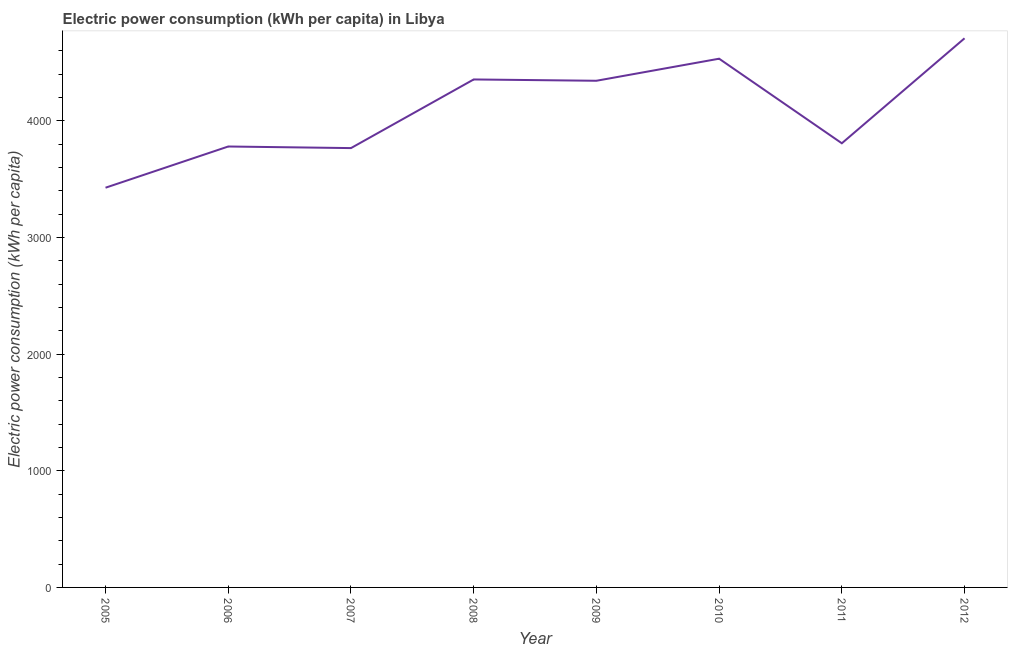What is the electric power consumption in 2006?
Your response must be concise. 3779.32. Across all years, what is the maximum electric power consumption?
Offer a very short reply. 4706.84. Across all years, what is the minimum electric power consumption?
Give a very brief answer. 3426.16. What is the sum of the electric power consumption?
Offer a terse response. 3.27e+04. What is the difference between the electric power consumption in 2006 and 2007?
Make the answer very short. 13.65. What is the average electric power consumption per year?
Provide a short and direct response. 4089.23. What is the median electric power consumption?
Provide a short and direct response. 4074.9. Do a majority of the years between 2006 and 2012 (inclusive) have electric power consumption greater than 2200 kWh per capita?
Make the answer very short. Yes. What is the ratio of the electric power consumption in 2006 to that in 2007?
Provide a short and direct response. 1. Is the electric power consumption in 2006 less than that in 2010?
Offer a very short reply. Yes. What is the difference between the highest and the second highest electric power consumption?
Keep it short and to the point. 174.87. What is the difference between the highest and the lowest electric power consumption?
Ensure brevity in your answer.  1280.69. Does the electric power consumption monotonically increase over the years?
Your answer should be compact. No. How many lines are there?
Make the answer very short. 1. What is the difference between two consecutive major ticks on the Y-axis?
Your answer should be compact. 1000. What is the title of the graph?
Provide a short and direct response. Electric power consumption (kWh per capita) in Libya. What is the label or title of the X-axis?
Provide a short and direct response. Year. What is the label or title of the Y-axis?
Ensure brevity in your answer.  Electric power consumption (kWh per capita). What is the Electric power consumption (kWh per capita) of 2005?
Your answer should be very brief. 3426.16. What is the Electric power consumption (kWh per capita) in 2006?
Provide a succinct answer. 3779.32. What is the Electric power consumption (kWh per capita) in 2007?
Your response must be concise. 3765.67. What is the Electric power consumption (kWh per capita) in 2008?
Give a very brief answer. 4354.06. What is the Electric power consumption (kWh per capita) in 2009?
Give a very brief answer. 4342.79. What is the Electric power consumption (kWh per capita) in 2010?
Your answer should be very brief. 4531.98. What is the Electric power consumption (kWh per capita) in 2011?
Provide a short and direct response. 3807.02. What is the Electric power consumption (kWh per capita) of 2012?
Provide a short and direct response. 4706.84. What is the difference between the Electric power consumption (kWh per capita) in 2005 and 2006?
Your response must be concise. -353.16. What is the difference between the Electric power consumption (kWh per capita) in 2005 and 2007?
Provide a short and direct response. -339.51. What is the difference between the Electric power consumption (kWh per capita) in 2005 and 2008?
Offer a terse response. -927.9. What is the difference between the Electric power consumption (kWh per capita) in 2005 and 2009?
Offer a very short reply. -916.63. What is the difference between the Electric power consumption (kWh per capita) in 2005 and 2010?
Provide a short and direct response. -1105.82. What is the difference between the Electric power consumption (kWh per capita) in 2005 and 2011?
Ensure brevity in your answer.  -380.86. What is the difference between the Electric power consumption (kWh per capita) in 2005 and 2012?
Keep it short and to the point. -1280.69. What is the difference between the Electric power consumption (kWh per capita) in 2006 and 2007?
Your response must be concise. 13.65. What is the difference between the Electric power consumption (kWh per capita) in 2006 and 2008?
Offer a terse response. -574.74. What is the difference between the Electric power consumption (kWh per capita) in 2006 and 2009?
Provide a short and direct response. -563.47. What is the difference between the Electric power consumption (kWh per capita) in 2006 and 2010?
Your answer should be compact. -752.66. What is the difference between the Electric power consumption (kWh per capita) in 2006 and 2011?
Your response must be concise. -27.7. What is the difference between the Electric power consumption (kWh per capita) in 2006 and 2012?
Ensure brevity in your answer.  -927.53. What is the difference between the Electric power consumption (kWh per capita) in 2007 and 2008?
Your response must be concise. -588.39. What is the difference between the Electric power consumption (kWh per capita) in 2007 and 2009?
Your answer should be compact. -577.13. What is the difference between the Electric power consumption (kWh per capita) in 2007 and 2010?
Provide a short and direct response. -766.31. What is the difference between the Electric power consumption (kWh per capita) in 2007 and 2011?
Give a very brief answer. -41.35. What is the difference between the Electric power consumption (kWh per capita) in 2007 and 2012?
Ensure brevity in your answer.  -941.18. What is the difference between the Electric power consumption (kWh per capita) in 2008 and 2009?
Your answer should be compact. 11.27. What is the difference between the Electric power consumption (kWh per capita) in 2008 and 2010?
Offer a terse response. -177.92. What is the difference between the Electric power consumption (kWh per capita) in 2008 and 2011?
Keep it short and to the point. 547.04. What is the difference between the Electric power consumption (kWh per capita) in 2008 and 2012?
Offer a very short reply. -352.79. What is the difference between the Electric power consumption (kWh per capita) in 2009 and 2010?
Give a very brief answer. -189.19. What is the difference between the Electric power consumption (kWh per capita) in 2009 and 2011?
Provide a short and direct response. 535.77. What is the difference between the Electric power consumption (kWh per capita) in 2009 and 2012?
Make the answer very short. -364.05. What is the difference between the Electric power consumption (kWh per capita) in 2010 and 2011?
Provide a succinct answer. 724.96. What is the difference between the Electric power consumption (kWh per capita) in 2010 and 2012?
Your answer should be compact. -174.87. What is the difference between the Electric power consumption (kWh per capita) in 2011 and 2012?
Give a very brief answer. -899.83. What is the ratio of the Electric power consumption (kWh per capita) in 2005 to that in 2006?
Offer a very short reply. 0.91. What is the ratio of the Electric power consumption (kWh per capita) in 2005 to that in 2007?
Give a very brief answer. 0.91. What is the ratio of the Electric power consumption (kWh per capita) in 2005 to that in 2008?
Ensure brevity in your answer.  0.79. What is the ratio of the Electric power consumption (kWh per capita) in 2005 to that in 2009?
Your answer should be very brief. 0.79. What is the ratio of the Electric power consumption (kWh per capita) in 2005 to that in 2010?
Keep it short and to the point. 0.76. What is the ratio of the Electric power consumption (kWh per capita) in 2005 to that in 2011?
Provide a succinct answer. 0.9. What is the ratio of the Electric power consumption (kWh per capita) in 2005 to that in 2012?
Offer a terse response. 0.73. What is the ratio of the Electric power consumption (kWh per capita) in 2006 to that in 2008?
Provide a succinct answer. 0.87. What is the ratio of the Electric power consumption (kWh per capita) in 2006 to that in 2009?
Your response must be concise. 0.87. What is the ratio of the Electric power consumption (kWh per capita) in 2006 to that in 2010?
Make the answer very short. 0.83. What is the ratio of the Electric power consumption (kWh per capita) in 2006 to that in 2012?
Your answer should be compact. 0.8. What is the ratio of the Electric power consumption (kWh per capita) in 2007 to that in 2008?
Keep it short and to the point. 0.86. What is the ratio of the Electric power consumption (kWh per capita) in 2007 to that in 2009?
Provide a short and direct response. 0.87. What is the ratio of the Electric power consumption (kWh per capita) in 2007 to that in 2010?
Offer a very short reply. 0.83. What is the ratio of the Electric power consumption (kWh per capita) in 2007 to that in 2011?
Your response must be concise. 0.99. What is the ratio of the Electric power consumption (kWh per capita) in 2008 to that in 2010?
Your response must be concise. 0.96. What is the ratio of the Electric power consumption (kWh per capita) in 2008 to that in 2011?
Your answer should be compact. 1.14. What is the ratio of the Electric power consumption (kWh per capita) in 2008 to that in 2012?
Offer a terse response. 0.93. What is the ratio of the Electric power consumption (kWh per capita) in 2009 to that in 2010?
Offer a terse response. 0.96. What is the ratio of the Electric power consumption (kWh per capita) in 2009 to that in 2011?
Provide a short and direct response. 1.14. What is the ratio of the Electric power consumption (kWh per capita) in 2009 to that in 2012?
Keep it short and to the point. 0.92. What is the ratio of the Electric power consumption (kWh per capita) in 2010 to that in 2011?
Your answer should be very brief. 1.19. What is the ratio of the Electric power consumption (kWh per capita) in 2011 to that in 2012?
Your response must be concise. 0.81. 